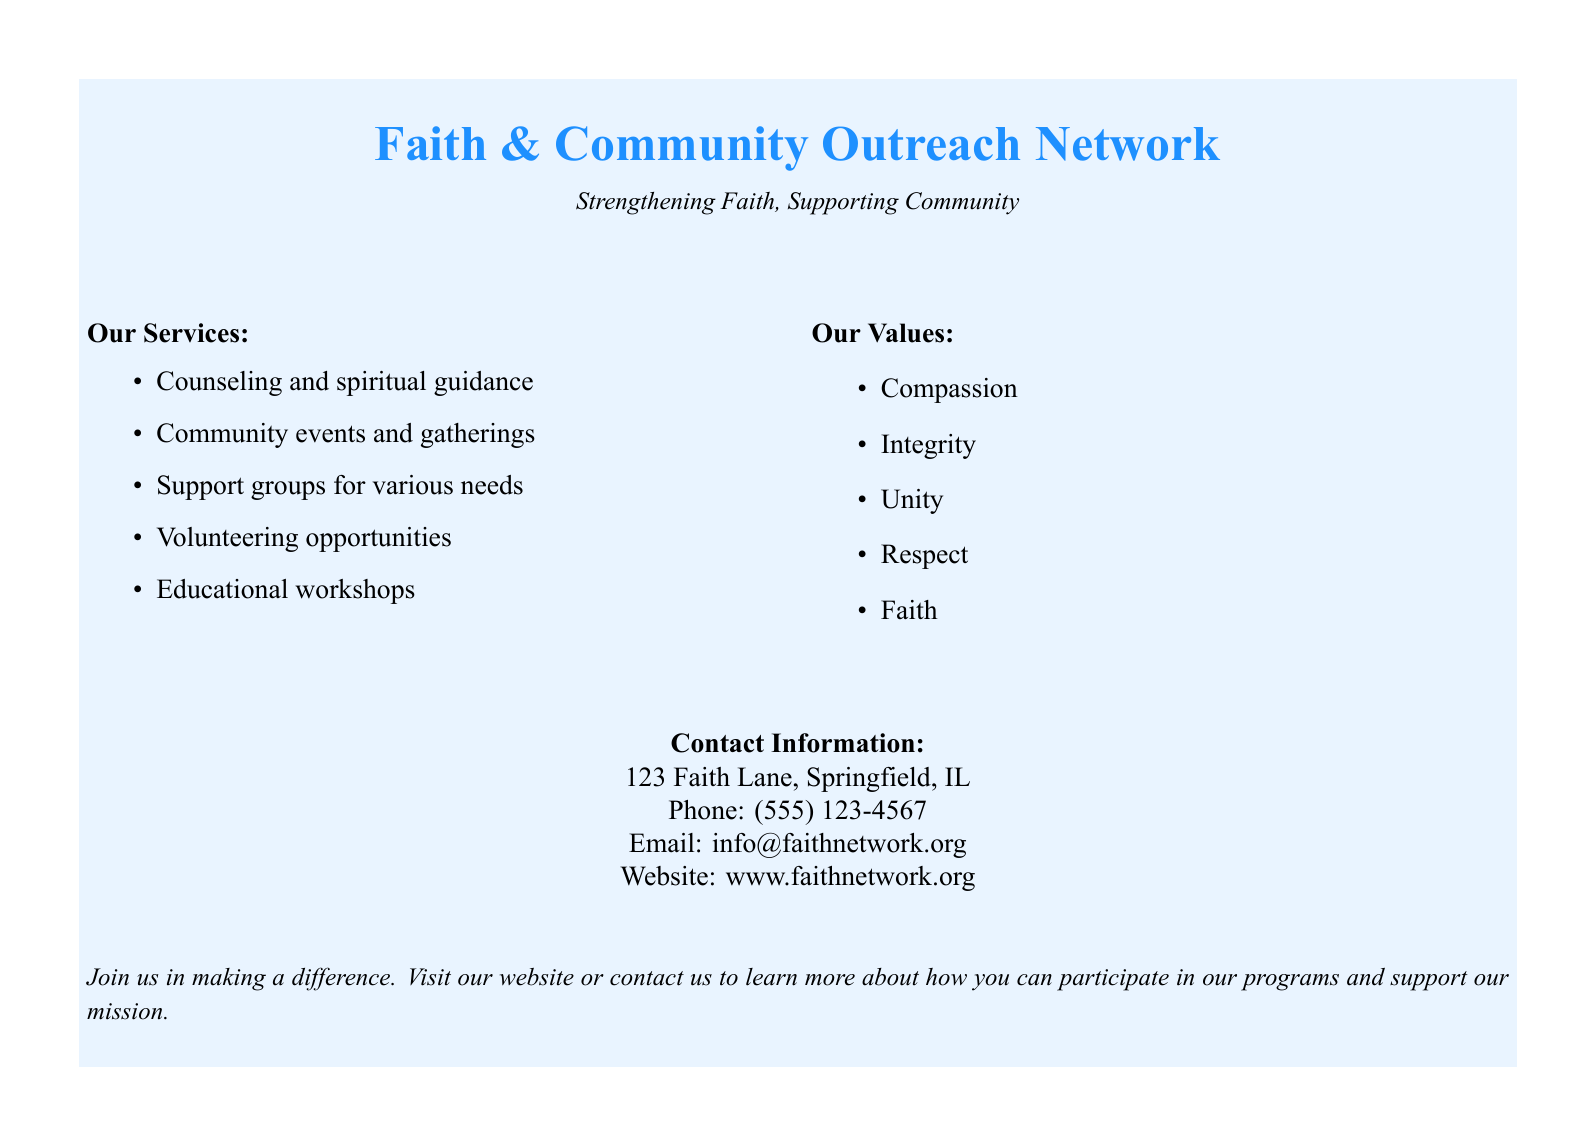what is the name of the organization? The name of the organization is mentioned in the document in the title, which reads "Faith & Community Outreach Network."
Answer: Faith & Community Outreach Network what is the address of the organization? The address is located in the contact section of the document, listed as "123 Faith Lane, Springfield, IL."
Answer: 123 Faith Lane, Springfield, IL what is the phone number provided? The phone number is specified in the contact section as "(555) 123-4567."
Answer: (555) 123-4567 which service focuses on personal issues? The service that focuses on personal issues is implied in the list of services and is known as "Counseling and spiritual guidance."
Answer: Counseling and spiritual guidance how many values are listed in the document? The number of values is calculated by counting the items in the "Our Values" section. There are five values listed.
Answer: 5 what is the primary goal stated in the document? The primary goal is expressed in the tagline under the title, which states "Strengthening Faith, Supporting Community."
Answer: Strengthening Faith, Supporting Community does the organization offer educational workshops? The services section includes various offerings, specifically mentioning "Educational workshops."
Answer: Yes what type of events does the organization conduct? The document specifies types of community gatherings, referring to them as "Community events and gatherings."
Answer: Community events and gatherings what mode of contact is listed aside from the phone number? The mode of contact mentioned in addition to the phone number is shown in the contact section as an email address.
Answer: Email what is the website for the organization? The website is included in the contact information section, which reads "www.faithnetwork.org."
Answer: www.faithnetwork.org 